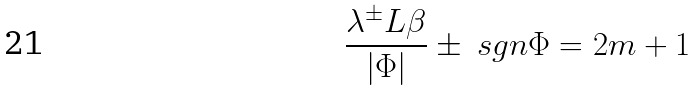Convert formula to latex. <formula><loc_0><loc_0><loc_500><loc_500>\frac { \lambda ^ { \pm } L \beta } { | \Phi | } \pm \ s g n \Phi = 2 m + 1</formula> 